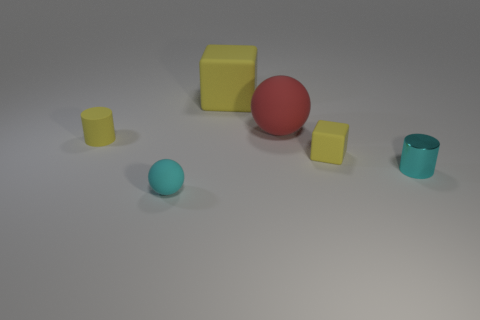Add 1 big purple shiny blocks. How many objects exist? 7 Subtract all balls. How many objects are left? 4 Subtract 0 blue cylinders. How many objects are left? 6 Subtract all tiny brown spheres. Subtract all yellow rubber cubes. How many objects are left? 4 Add 1 tiny cyan metal things. How many tiny cyan metal things are left? 2 Add 4 red objects. How many red objects exist? 5 